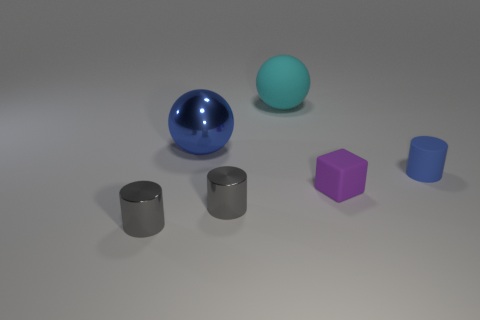Subtract all small rubber cylinders. How many cylinders are left? 2 Add 3 blue balls. How many objects exist? 9 Subtract all gray cylinders. How many cylinders are left? 1 Subtract all cubes. How many objects are left? 5 Add 2 tiny purple cubes. How many tiny purple cubes exist? 3 Subtract 0 purple balls. How many objects are left? 6 Subtract 1 cylinders. How many cylinders are left? 2 Subtract all purple balls. Subtract all red cubes. How many balls are left? 2 Subtract all blue blocks. How many yellow balls are left? 0 Subtract all blue balls. Subtract all blue metallic objects. How many objects are left? 4 